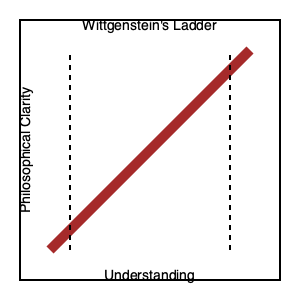How does Conant's interpretation of Wittgenstein's ladder metaphor differ from the traditional view, and what implications does this have for understanding the Tractatus? 1. Traditional view of Wittgenstein's ladder:
   - The ladder represents a series of propositions in the Tractatus.
   - Readers climb the ladder to reach a higher understanding.
   - Once at the top, the ladder (propositions) can be discarded.

2. Conant's interpretation:
   - The ladder is not a series of substantial doctrines to be climbed.
   - Instead, it represents the illusion of philosophical progress.
   - The entire ladder is nonsensical and meant to be recognized as such.

3. Implications for understanding the Tractatus:
   - Traditional view: The Tractatus contains meaningful propositions that lead to ineffable truths.
   - Conant's view: The Tractatus is entirely composed of nonsense, designed to show the limits of language.

4. Conant's "resolute reading":
   - Emphasizes the therapeutic nature of Wittgenstein's work.
   - Aims to cure readers of the desire for a theoretical philosophy.
   - Suggests that trying to extract positive doctrines from the Tractatus is misguided.

5. The purpose of the ladder:
   - Traditional view: To reach a mystical insight beyond language.
   - Conant's view: To recognize the futility of traditional philosophical methods.

6. Implications for philosophical practice:
   - Encourages a shift from theory-building to conceptual clarification.
   - Emphasizes the importance of ordinary language in philosophical inquiry.
   - Challenges the notion of philosophy as a body of doctrines.
Answer: Conant interprets the ladder as an illusion of philosophical progress, not a series of meaningful propositions, implying the Tractatus is entirely nonsensical and therapeutic rather than doctrinally substantive. 